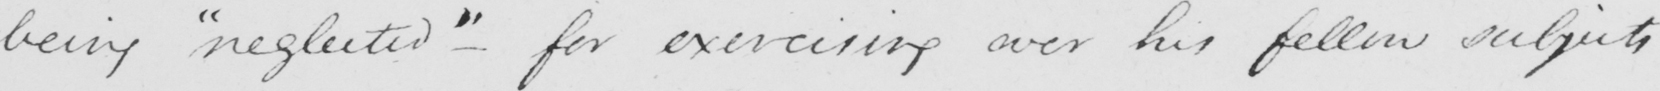What does this handwritten line say? being  " neglected "  - for exercising over his fellow subjects 